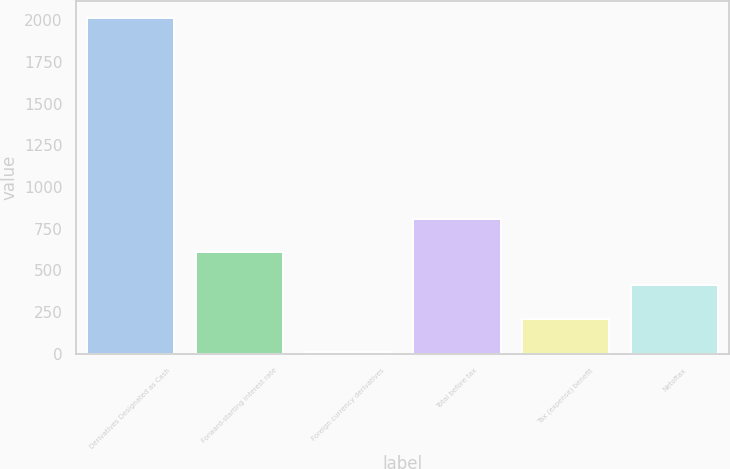Convert chart to OTSL. <chart><loc_0><loc_0><loc_500><loc_500><bar_chart><fcel>Derivatives Designated as Cash<fcel>Forward-starting interest rate<fcel>Foreign currency derivatives<fcel>Total before tax<fcel>Tax (expense) benefit<fcel>Netoftax<nl><fcel>2012<fcel>609.9<fcel>9<fcel>810.2<fcel>209.3<fcel>409.6<nl></chart> 